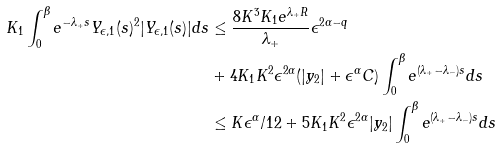<formula> <loc_0><loc_0><loc_500><loc_500>K _ { 1 } \int _ { 0 } ^ { \beta } e ^ { - \lambda _ { + } s } Y _ { \epsilon , 1 } ( s ) ^ { 2 } | Y _ { \epsilon , 1 } ( s ) | d s & \leq \frac { 8 K ^ { 3 } K _ { 1 } e ^ { \lambda _ { + } R } } { \lambda _ { + } } \epsilon ^ { 2 \alpha - q } \\ & + 4 K _ { 1 } K ^ { 2 } \epsilon ^ { 2 \alpha } ( | y _ { 2 } | + \epsilon ^ { \alpha } C ) \int _ { 0 } ^ { \beta } e ^ { ( \lambda _ { + } - \lambda _ { - } ) s } d s \\ & \leq K \epsilon ^ { \alpha } / 1 2 + 5 K _ { 1 } K ^ { 2 } \epsilon ^ { 2 \alpha } | y _ { 2 } | \int _ { 0 } ^ { \beta } e ^ { ( \lambda _ { + } - \lambda _ { - } ) s } d s</formula> 